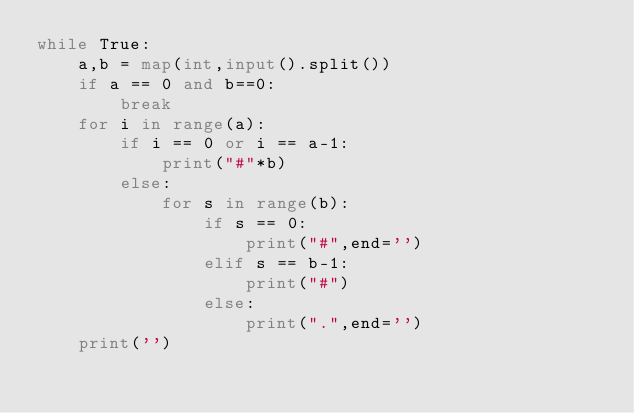<code> <loc_0><loc_0><loc_500><loc_500><_Python_>while True:
    a,b = map(int,input().split())
    if a == 0 and b==0:
        break
    for i in range(a):
        if i == 0 or i == a-1:
            print("#"*b)
        else:
            for s in range(b):
                if s == 0:
                    print("#",end='')
                elif s == b-1:
                    print("#")
                else:
                    print(".",end='')
    print('')
</code> 